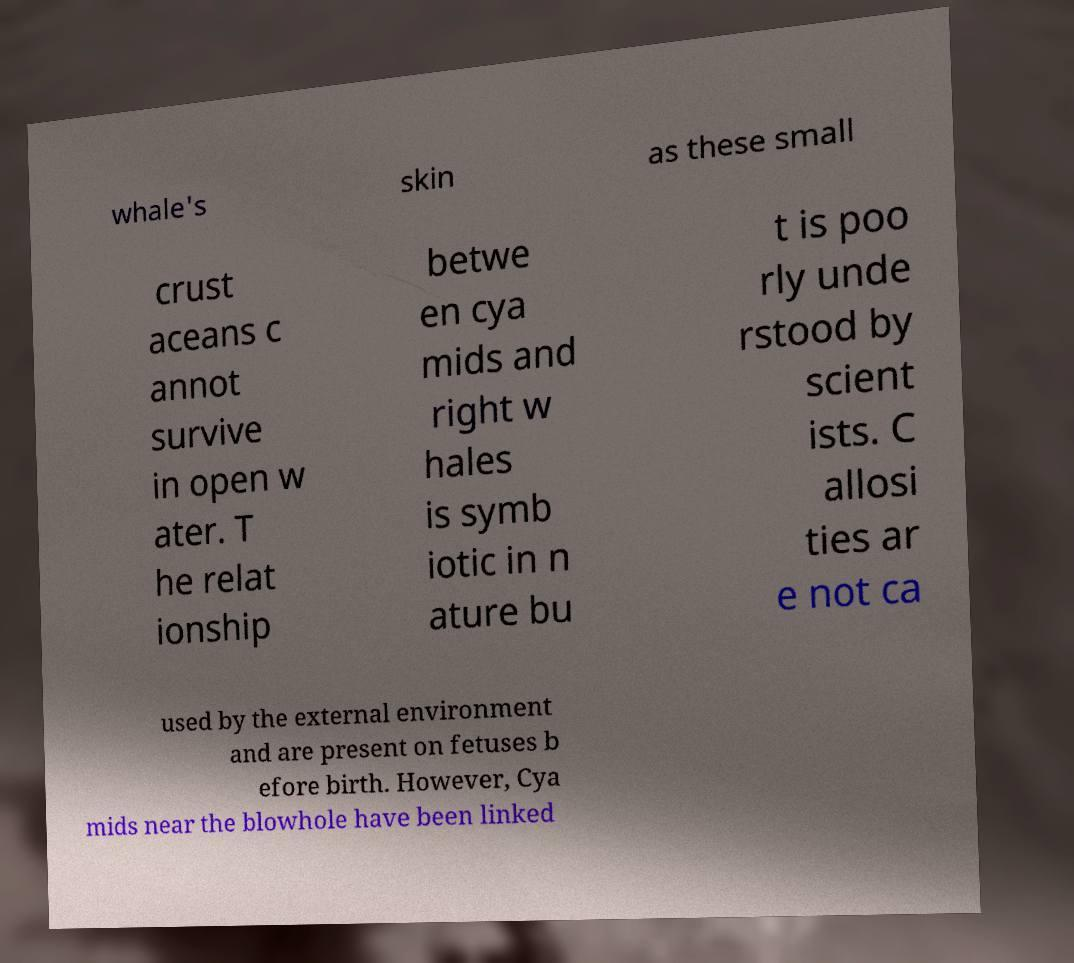Can you read and provide the text displayed in the image?This photo seems to have some interesting text. Can you extract and type it out for me? whale's skin as these small crust aceans c annot survive in open w ater. T he relat ionship betwe en cya mids and right w hales is symb iotic in n ature bu t is poo rly unde rstood by scient ists. C allosi ties ar e not ca used by the external environment and are present on fetuses b efore birth. However, Cya mids near the blowhole have been linked 